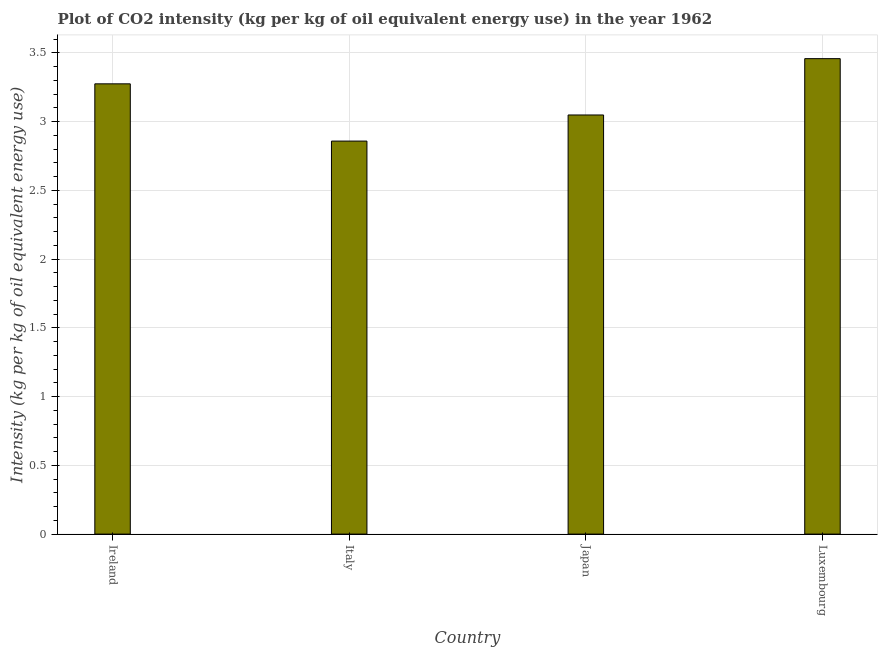Does the graph contain any zero values?
Make the answer very short. No. What is the title of the graph?
Provide a succinct answer. Plot of CO2 intensity (kg per kg of oil equivalent energy use) in the year 1962. What is the label or title of the X-axis?
Your answer should be very brief. Country. What is the label or title of the Y-axis?
Provide a short and direct response. Intensity (kg per kg of oil equivalent energy use). What is the co2 intensity in Japan?
Give a very brief answer. 3.05. Across all countries, what is the maximum co2 intensity?
Provide a succinct answer. 3.46. Across all countries, what is the minimum co2 intensity?
Provide a short and direct response. 2.86. In which country was the co2 intensity maximum?
Provide a short and direct response. Luxembourg. What is the sum of the co2 intensity?
Keep it short and to the point. 12.64. What is the average co2 intensity per country?
Give a very brief answer. 3.16. What is the median co2 intensity?
Your answer should be compact. 3.16. In how many countries, is the co2 intensity greater than 1.3 kg?
Ensure brevity in your answer.  4. What is the ratio of the co2 intensity in Italy to that in Luxembourg?
Your answer should be compact. 0.83. Is the difference between the co2 intensity in Ireland and Japan greater than the difference between any two countries?
Your answer should be compact. No. What is the difference between the highest and the second highest co2 intensity?
Your answer should be compact. 0.18. Is the sum of the co2 intensity in Ireland and Luxembourg greater than the maximum co2 intensity across all countries?
Offer a very short reply. Yes. What is the difference between the highest and the lowest co2 intensity?
Offer a terse response. 0.6. In how many countries, is the co2 intensity greater than the average co2 intensity taken over all countries?
Offer a terse response. 2. Are all the bars in the graph horizontal?
Your answer should be compact. No. How many countries are there in the graph?
Your response must be concise. 4. Are the values on the major ticks of Y-axis written in scientific E-notation?
Make the answer very short. No. What is the Intensity (kg per kg of oil equivalent energy use) of Ireland?
Offer a terse response. 3.27. What is the Intensity (kg per kg of oil equivalent energy use) in Italy?
Your response must be concise. 2.86. What is the Intensity (kg per kg of oil equivalent energy use) of Japan?
Keep it short and to the point. 3.05. What is the Intensity (kg per kg of oil equivalent energy use) in Luxembourg?
Give a very brief answer. 3.46. What is the difference between the Intensity (kg per kg of oil equivalent energy use) in Ireland and Italy?
Give a very brief answer. 0.42. What is the difference between the Intensity (kg per kg of oil equivalent energy use) in Ireland and Japan?
Your answer should be very brief. 0.23. What is the difference between the Intensity (kg per kg of oil equivalent energy use) in Ireland and Luxembourg?
Provide a succinct answer. -0.18. What is the difference between the Intensity (kg per kg of oil equivalent energy use) in Italy and Japan?
Your response must be concise. -0.19. What is the difference between the Intensity (kg per kg of oil equivalent energy use) in Italy and Luxembourg?
Keep it short and to the point. -0.6. What is the difference between the Intensity (kg per kg of oil equivalent energy use) in Japan and Luxembourg?
Offer a very short reply. -0.41. What is the ratio of the Intensity (kg per kg of oil equivalent energy use) in Ireland to that in Italy?
Your response must be concise. 1.15. What is the ratio of the Intensity (kg per kg of oil equivalent energy use) in Ireland to that in Japan?
Make the answer very short. 1.07. What is the ratio of the Intensity (kg per kg of oil equivalent energy use) in Ireland to that in Luxembourg?
Provide a short and direct response. 0.95. What is the ratio of the Intensity (kg per kg of oil equivalent energy use) in Italy to that in Japan?
Offer a terse response. 0.94. What is the ratio of the Intensity (kg per kg of oil equivalent energy use) in Italy to that in Luxembourg?
Offer a very short reply. 0.83. What is the ratio of the Intensity (kg per kg of oil equivalent energy use) in Japan to that in Luxembourg?
Your answer should be very brief. 0.88. 